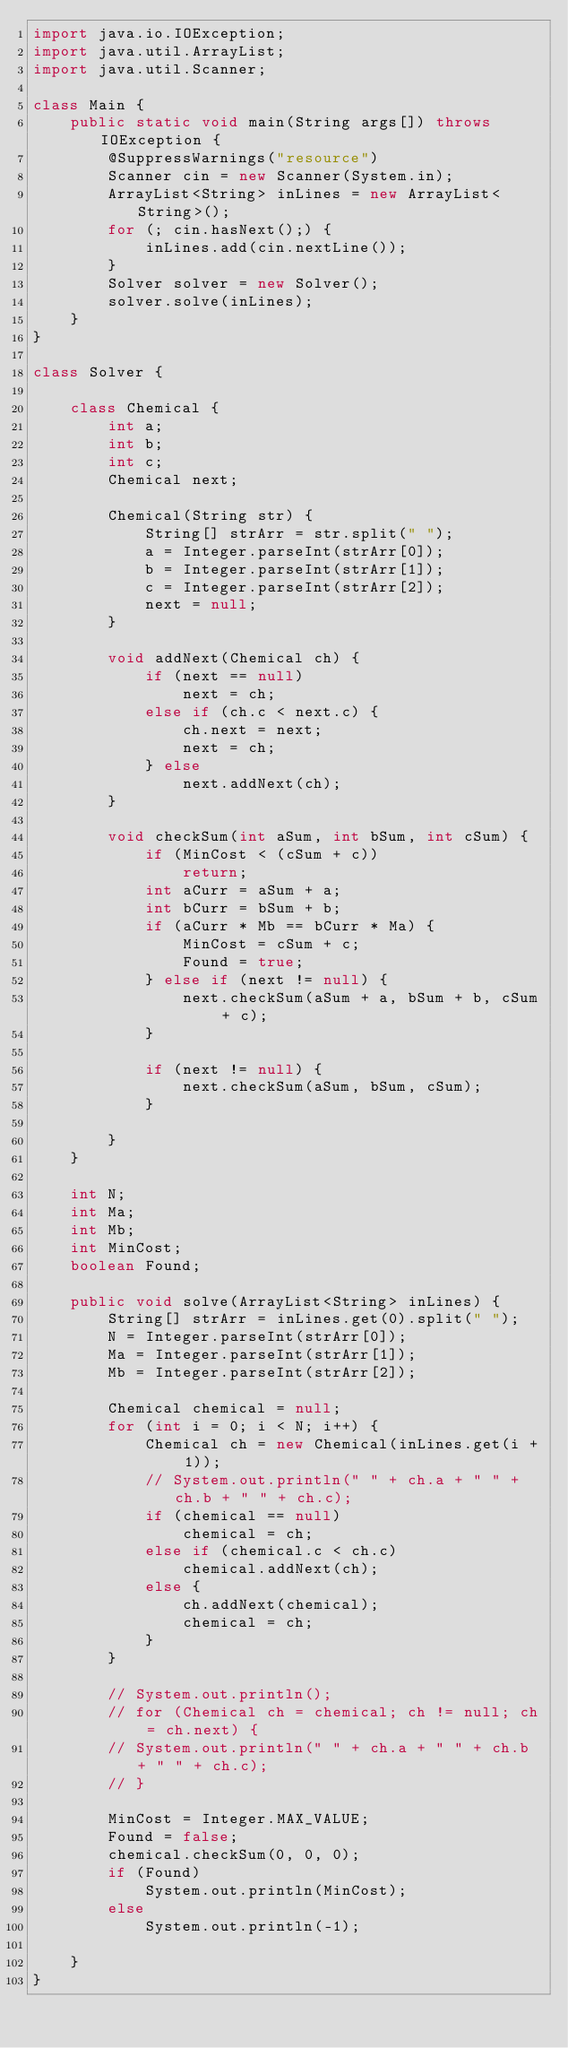Convert code to text. <code><loc_0><loc_0><loc_500><loc_500><_Java_>import java.io.IOException;
import java.util.ArrayList;
import java.util.Scanner;

class Main {
	public static void main(String args[]) throws IOException {
		@SuppressWarnings("resource")
		Scanner cin = new Scanner(System.in);
		ArrayList<String> inLines = new ArrayList<String>();
		for (; cin.hasNext();) {
			inLines.add(cin.nextLine());
		}
		Solver solver = new Solver();
		solver.solve(inLines);
	}
}

class Solver {

	class Chemical {
		int a;
		int b;
		int c;
		Chemical next;

		Chemical(String str) {
			String[] strArr = str.split(" ");
			a = Integer.parseInt(strArr[0]);
			b = Integer.parseInt(strArr[1]);
			c = Integer.parseInt(strArr[2]);
			next = null;
		}

		void addNext(Chemical ch) {
			if (next == null)
				next = ch;
			else if (ch.c < next.c) {
				ch.next = next;
				next = ch;
			} else
				next.addNext(ch);
		}

		void checkSum(int aSum, int bSum, int cSum) {
			if (MinCost < (cSum + c))
				return;
			int aCurr = aSum + a;
			int bCurr = bSum + b;
			if (aCurr * Mb == bCurr * Ma) {
				MinCost = cSum + c;
				Found = true;
			} else if (next != null) {
				next.checkSum(aSum + a, bSum + b, cSum + c);
			}

			if (next != null) {
				next.checkSum(aSum, bSum, cSum);
			}

		}
	}

	int N;
	int Ma;
	int Mb;
	int MinCost;
	boolean Found;

	public void solve(ArrayList<String> inLines) {
		String[] strArr = inLines.get(0).split(" ");
		N = Integer.parseInt(strArr[0]);
		Ma = Integer.parseInt(strArr[1]);
		Mb = Integer.parseInt(strArr[2]);

		Chemical chemical = null;
		for (int i = 0; i < N; i++) {
			Chemical ch = new Chemical(inLines.get(i + 1));
			// System.out.println(" " + ch.a + " " + ch.b + " " + ch.c);
			if (chemical == null)
				chemical = ch;
			else if (chemical.c < ch.c)
				chemical.addNext(ch);
			else {
				ch.addNext(chemical);
				chemical = ch;
			}
		}

		// System.out.println();
		// for (Chemical ch = chemical; ch != null; ch = ch.next) {
		// System.out.println(" " + ch.a + " " + ch.b + " " + ch.c);
		// }

		MinCost = Integer.MAX_VALUE;
		Found = false;
		chemical.checkSum(0, 0, 0);
		if (Found)
			System.out.println(MinCost);
		else
			System.out.println(-1);

	}
}
</code> 